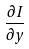Convert formula to latex. <formula><loc_0><loc_0><loc_500><loc_500>\frac { \partial I } { \partial y }</formula> 